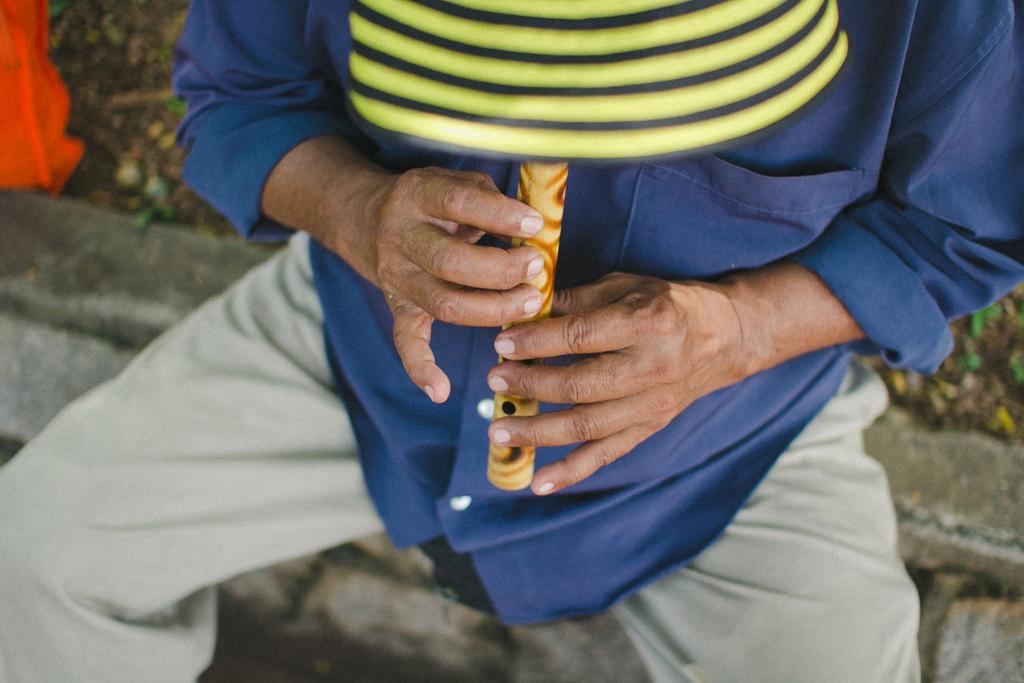Could you give a brief overview of what you see in this image? In this picture there is a man in the center of the image, by holding a flute in his hands. 